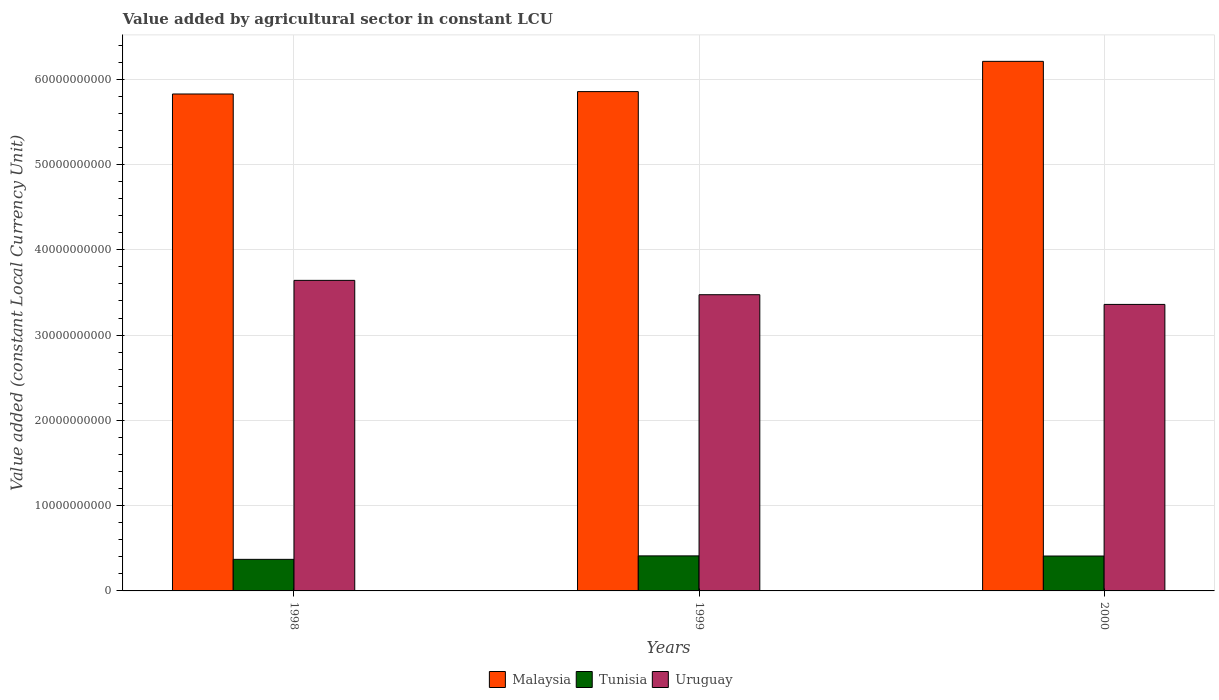Are the number of bars per tick equal to the number of legend labels?
Your answer should be very brief. Yes. Are the number of bars on each tick of the X-axis equal?
Your answer should be compact. Yes. How many bars are there on the 2nd tick from the right?
Your answer should be very brief. 3. In how many cases, is the number of bars for a given year not equal to the number of legend labels?
Make the answer very short. 0. What is the value added by agricultural sector in Malaysia in 1999?
Your response must be concise. 5.86e+1. Across all years, what is the maximum value added by agricultural sector in Malaysia?
Offer a very short reply. 6.21e+1. Across all years, what is the minimum value added by agricultural sector in Malaysia?
Your answer should be compact. 5.83e+1. In which year was the value added by agricultural sector in Uruguay maximum?
Your answer should be very brief. 1998. In which year was the value added by agricultural sector in Tunisia minimum?
Your answer should be very brief. 1998. What is the total value added by agricultural sector in Tunisia in the graph?
Offer a very short reply. 1.19e+1. What is the difference between the value added by agricultural sector in Malaysia in 1998 and that in 1999?
Provide a succinct answer. -2.80e+08. What is the difference between the value added by agricultural sector in Tunisia in 2000 and the value added by agricultural sector in Uruguay in 1999?
Provide a succinct answer. -3.06e+1. What is the average value added by agricultural sector in Tunisia per year?
Offer a terse response. 3.97e+09. In the year 1998, what is the difference between the value added by agricultural sector in Uruguay and value added by agricultural sector in Malaysia?
Ensure brevity in your answer.  -2.19e+1. In how many years, is the value added by agricultural sector in Malaysia greater than 8000000000 LCU?
Your answer should be very brief. 3. What is the ratio of the value added by agricultural sector in Malaysia in 1999 to that in 2000?
Give a very brief answer. 0.94. What is the difference between the highest and the second highest value added by agricultural sector in Tunisia?
Give a very brief answer. 1.57e+07. What is the difference between the highest and the lowest value added by agricultural sector in Uruguay?
Provide a succinct answer. 2.82e+09. In how many years, is the value added by agricultural sector in Tunisia greater than the average value added by agricultural sector in Tunisia taken over all years?
Keep it short and to the point. 2. What does the 2nd bar from the left in 1998 represents?
Provide a succinct answer. Tunisia. What does the 3rd bar from the right in 1999 represents?
Ensure brevity in your answer.  Malaysia. Is it the case that in every year, the sum of the value added by agricultural sector in Tunisia and value added by agricultural sector in Uruguay is greater than the value added by agricultural sector in Malaysia?
Keep it short and to the point. No. Are all the bars in the graph horizontal?
Make the answer very short. No. How many years are there in the graph?
Ensure brevity in your answer.  3. Are the values on the major ticks of Y-axis written in scientific E-notation?
Your answer should be very brief. No. Does the graph contain any zero values?
Your response must be concise. No. Does the graph contain grids?
Provide a short and direct response. Yes. Where does the legend appear in the graph?
Give a very brief answer. Bottom center. What is the title of the graph?
Keep it short and to the point. Value added by agricultural sector in constant LCU. Does "West Bank and Gaza" appear as one of the legend labels in the graph?
Give a very brief answer. No. What is the label or title of the Y-axis?
Your answer should be compact. Value added (constant Local Currency Unit). What is the Value added (constant Local Currency Unit) of Malaysia in 1998?
Provide a short and direct response. 5.83e+1. What is the Value added (constant Local Currency Unit) of Tunisia in 1998?
Your answer should be very brief. 3.70e+09. What is the Value added (constant Local Currency Unit) in Uruguay in 1998?
Your answer should be very brief. 3.64e+1. What is the Value added (constant Local Currency Unit) in Malaysia in 1999?
Your answer should be very brief. 5.86e+1. What is the Value added (constant Local Currency Unit) in Tunisia in 1999?
Make the answer very short. 4.11e+09. What is the Value added (constant Local Currency Unit) in Uruguay in 1999?
Provide a succinct answer. 3.47e+1. What is the Value added (constant Local Currency Unit) in Malaysia in 2000?
Ensure brevity in your answer.  6.21e+1. What is the Value added (constant Local Currency Unit) of Tunisia in 2000?
Provide a short and direct response. 4.09e+09. What is the Value added (constant Local Currency Unit) in Uruguay in 2000?
Give a very brief answer. 3.36e+1. Across all years, what is the maximum Value added (constant Local Currency Unit) of Malaysia?
Provide a short and direct response. 6.21e+1. Across all years, what is the maximum Value added (constant Local Currency Unit) of Tunisia?
Keep it short and to the point. 4.11e+09. Across all years, what is the maximum Value added (constant Local Currency Unit) in Uruguay?
Keep it short and to the point. 3.64e+1. Across all years, what is the minimum Value added (constant Local Currency Unit) of Malaysia?
Give a very brief answer. 5.83e+1. Across all years, what is the minimum Value added (constant Local Currency Unit) in Tunisia?
Offer a very short reply. 3.70e+09. Across all years, what is the minimum Value added (constant Local Currency Unit) in Uruguay?
Your response must be concise. 3.36e+1. What is the total Value added (constant Local Currency Unit) of Malaysia in the graph?
Offer a very short reply. 1.79e+11. What is the total Value added (constant Local Currency Unit) in Tunisia in the graph?
Offer a terse response. 1.19e+1. What is the total Value added (constant Local Currency Unit) of Uruguay in the graph?
Provide a short and direct response. 1.05e+11. What is the difference between the Value added (constant Local Currency Unit) of Malaysia in 1998 and that in 1999?
Your answer should be very brief. -2.80e+08. What is the difference between the Value added (constant Local Currency Unit) in Tunisia in 1998 and that in 1999?
Your response must be concise. -4.07e+08. What is the difference between the Value added (constant Local Currency Unit) of Uruguay in 1998 and that in 1999?
Keep it short and to the point. 1.68e+09. What is the difference between the Value added (constant Local Currency Unit) of Malaysia in 1998 and that in 2000?
Your answer should be compact. -3.83e+09. What is the difference between the Value added (constant Local Currency Unit) in Tunisia in 1998 and that in 2000?
Your answer should be compact. -3.91e+08. What is the difference between the Value added (constant Local Currency Unit) in Uruguay in 1998 and that in 2000?
Provide a short and direct response. 2.82e+09. What is the difference between the Value added (constant Local Currency Unit) of Malaysia in 1999 and that in 2000?
Ensure brevity in your answer.  -3.55e+09. What is the difference between the Value added (constant Local Currency Unit) of Tunisia in 1999 and that in 2000?
Ensure brevity in your answer.  1.57e+07. What is the difference between the Value added (constant Local Currency Unit) of Uruguay in 1999 and that in 2000?
Your response must be concise. 1.14e+09. What is the difference between the Value added (constant Local Currency Unit) in Malaysia in 1998 and the Value added (constant Local Currency Unit) in Tunisia in 1999?
Provide a short and direct response. 5.42e+1. What is the difference between the Value added (constant Local Currency Unit) of Malaysia in 1998 and the Value added (constant Local Currency Unit) of Uruguay in 1999?
Keep it short and to the point. 2.35e+1. What is the difference between the Value added (constant Local Currency Unit) in Tunisia in 1998 and the Value added (constant Local Currency Unit) in Uruguay in 1999?
Give a very brief answer. -3.10e+1. What is the difference between the Value added (constant Local Currency Unit) in Malaysia in 1998 and the Value added (constant Local Currency Unit) in Tunisia in 2000?
Give a very brief answer. 5.42e+1. What is the difference between the Value added (constant Local Currency Unit) of Malaysia in 1998 and the Value added (constant Local Currency Unit) of Uruguay in 2000?
Keep it short and to the point. 2.47e+1. What is the difference between the Value added (constant Local Currency Unit) of Tunisia in 1998 and the Value added (constant Local Currency Unit) of Uruguay in 2000?
Make the answer very short. -2.99e+1. What is the difference between the Value added (constant Local Currency Unit) in Malaysia in 1999 and the Value added (constant Local Currency Unit) in Tunisia in 2000?
Ensure brevity in your answer.  5.45e+1. What is the difference between the Value added (constant Local Currency Unit) in Malaysia in 1999 and the Value added (constant Local Currency Unit) in Uruguay in 2000?
Offer a terse response. 2.50e+1. What is the difference between the Value added (constant Local Currency Unit) of Tunisia in 1999 and the Value added (constant Local Currency Unit) of Uruguay in 2000?
Your answer should be very brief. -2.95e+1. What is the average Value added (constant Local Currency Unit) in Malaysia per year?
Ensure brevity in your answer.  5.96e+1. What is the average Value added (constant Local Currency Unit) in Tunisia per year?
Keep it short and to the point. 3.97e+09. What is the average Value added (constant Local Currency Unit) in Uruguay per year?
Keep it short and to the point. 3.49e+1. In the year 1998, what is the difference between the Value added (constant Local Currency Unit) in Malaysia and Value added (constant Local Currency Unit) in Tunisia?
Offer a very short reply. 5.46e+1. In the year 1998, what is the difference between the Value added (constant Local Currency Unit) in Malaysia and Value added (constant Local Currency Unit) in Uruguay?
Your answer should be compact. 2.19e+1. In the year 1998, what is the difference between the Value added (constant Local Currency Unit) of Tunisia and Value added (constant Local Currency Unit) of Uruguay?
Offer a very short reply. -3.27e+1. In the year 1999, what is the difference between the Value added (constant Local Currency Unit) in Malaysia and Value added (constant Local Currency Unit) in Tunisia?
Ensure brevity in your answer.  5.44e+1. In the year 1999, what is the difference between the Value added (constant Local Currency Unit) of Malaysia and Value added (constant Local Currency Unit) of Uruguay?
Your answer should be compact. 2.38e+1. In the year 1999, what is the difference between the Value added (constant Local Currency Unit) of Tunisia and Value added (constant Local Currency Unit) of Uruguay?
Ensure brevity in your answer.  -3.06e+1. In the year 2000, what is the difference between the Value added (constant Local Currency Unit) of Malaysia and Value added (constant Local Currency Unit) of Tunisia?
Provide a short and direct response. 5.80e+1. In the year 2000, what is the difference between the Value added (constant Local Currency Unit) of Malaysia and Value added (constant Local Currency Unit) of Uruguay?
Give a very brief answer. 2.85e+1. In the year 2000, what is the difference between the Value added (constant Local Currency Unit) of Tunisia and Value added (constant Local Currency Unit) of Uruguay?
Your answer should be compact. -2.95e+1. What is the ratio of the Value added (constant Local Currency Unit) in Malaysia in 1998 to that in 1999?
Make the answer very short. 1. What is the ratio of the Value added (constant Local Currency Unit) in Tunisia in 1998 to that in 1999?
Give a very brief answer. 0.9. What is the ratio of the Value added (constant Local Currency Unit) in Uruguay in 1998 to that in 1999?
Ensure brevity in your answer.  1.05. What is the ratio of the Value added (constant Local Currency Unit) in Malaysia in 1998 to that in 2000?
Offer a very short reply. 0.94. What is the ratio of the Value added (constant Local Currency Unit) of Tunisia in 1998 to that in 2000?
Offer a very short reply. 0.9. What is the ratio of the Value added (constant Local Currency Unit) in Uruguay in 1998 to that in 2000?
Your answer should be very brief. 1.08. What is the ratio of the Value added (constant Local Currency Unit) of Malaysia in 1999 to that in 2000?
Keep it short and to the point. 0.94. What is the ratio of the Value added (constant Local Currency Unit) of Uruguay in 1999 to that in 2000?
Offer a terse response. 1.03. What is the difference between the highest and the second highest Value added (constant Local Currency Unit) of Malaysia?
Your answer should be compact. 3.55e+09. What is the difference between the highest and the second highest Value added (constant Local Currency Unit) in Tunisia?
Offer a very short reply. 1.57e+07. What is the difference between the highest and the second highest Value added (constant Local Currency Unit) of Uruguay?
Offer a terse response. 1.68e+09. What is the difference between the highest and the lowest Value added (constant Local Currency Unit) of Malaysia?
Keep it short and to the point. 3.83e+09. What is the difference between the highest and the lowest Value added (constant Local Currency Unit) in Tunisia?
Give a very brief answer. 4.07e+08. What is the difference between the highest and the lowest Value added (constant Local Currency Unit) of Uruguay?
Keep it short and to the point. 2.82e+09. 